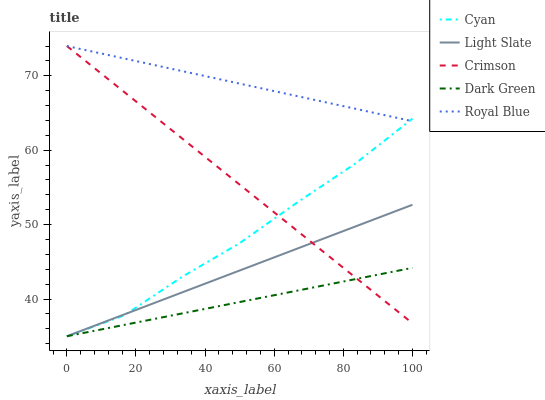Does Dark Green have the minimum area under the curve?
Answer yes or no. Yes. Does Royal Blue have the maximum area under the curve?
Answer yes or no. Yes. Does Cyan have the minimum area under the curve?
Answer yes or no. No. Does Cyan have the maximum area under the curve?
Answer yes or no. No. Is Light Slate the smoothest?
Answer yes or no. Yes. Is Cyan the roughest?
Answer yes or no. Yes. Is Royal Blue the smoothest?
Answer yes or no. No. Is Royal Blue the roughest?
Answer yes or no. No. Does Royal Blue have the lowest value?
Answer yes or no. No. Does Crimson have the highest value?
Answer yes or no. Yes. Does Cyan have the highest value?
Answer yes or no. No. Is Dark Green less than Royal Blue?
Answer yes or no. Yes. Is Royal Blue greater than Light Slate?
Answer yes or no. Yes. Does Crimson intersect Light Slate?
Answer yes or no. Yes. Is Crimson less than Light Slate?
Answer yes or no. No. Is Crimson greater than Light Slate?
Answer yes or no. No. Does Dark Green intersect Royal Blue?
Answer yes or no. No. 